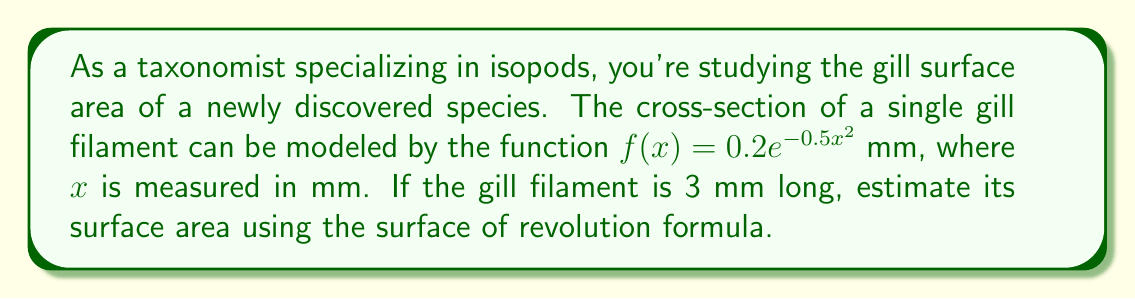Provide a solution to this math problem. To estimate the surface area of the gill filament, we'll use the surface of revolution formula:

$$A = 2\pi \int_{0}^{b} f(x)\sqrt{1 + [f'(x)]^2} dx$$

Where $f(x) = 0.2e^{-0.5x^2}$ and $b = 3$ mm.

Step 1: Find $f'(x)$
$$f'(x) = 0.2e^{-0.5x^2} \cdot (-x) = -0.2xe^{-0.5x^2}$$

Step 2: Set up the integral
$$A = 2\pi \int_{0}^{3} 0.2e^{-0.5x^2}\sqrt{1 + [0.2xe^{-0.5x^2}]^2} dx$$

Step 3: Simplify the integrand
$$A = 0.4\pi \int_{0}^{3} e^{-0.5x^2}\sqrt{1 + 0.04x^2e^{-x^2}} dx$$

Step 4: This integral cannot be evaluated analytically, so we need to use numerical integration. We can use Simpson's Rule with n = 6 subintervals:

$$\int_{a}^{b} f(x)dx \approx \frac{h}{3}[f(x_0) + 4f(x_1) + 2f(x_2) + 4f(x_3) + 2f(x_4) + 4f(x_5) + f(x_6)]$$

Where $h = \frac{b-a}{n} = \frac{3-0}{6} = 0.5$

Step 5: Calculate the function values at each point:
$f(0) \approx 0.2000$
$f(0.5) \approx 0.1951$
$f(1.0) \approx 0.1813$
$f(1.5) \approx 0.1609$
$f(2.0) \approx 0.1369$
$f(2.5) \approx 0.1127$
$f(3.0) \approx 0.0902$

Step 6: Apply Simpson's Rule
$$A \approx 0.4\pi \cdot \frac{0.5}{3}[0.2000 + 4(0.1951) + 2(0.1813) + 4(0.1609) + 2(0.1369) + 4(0.1127) + 0.0902]$$

Step 7: Calculate the final result
$$A \approx 0.4\pi \cdot 0.1667 \cdot 1.9320 \approx 0.4042 \text{ mm}^2$$
Answer: $0.4042 \text{ mm}^2$ 